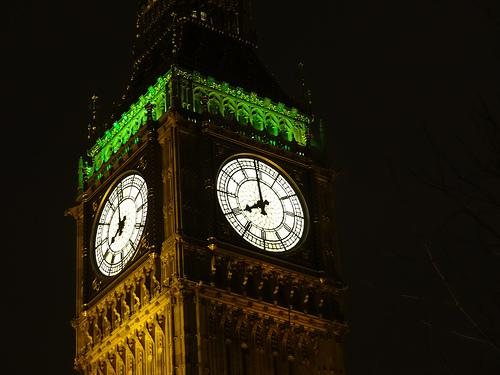Question: when was the picture taken?
Choices:
A. In the morning.
B. In the afternoon.
C. In the evening.
D. At night.
Answer with the letter. Answer: D 